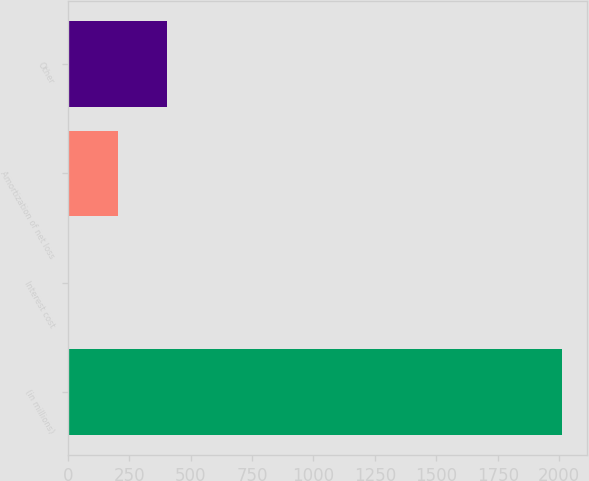<chart> <loc_0><loc_0><loc_500><loc_500><bar_chart><fcel>(in millions)<fcel>Interest cost<fcel>Amortization of net loss<fcel>Other<nl><fcel>2011<fcel>2<fcel>202.9<fcel>403.8<nl></chart> 